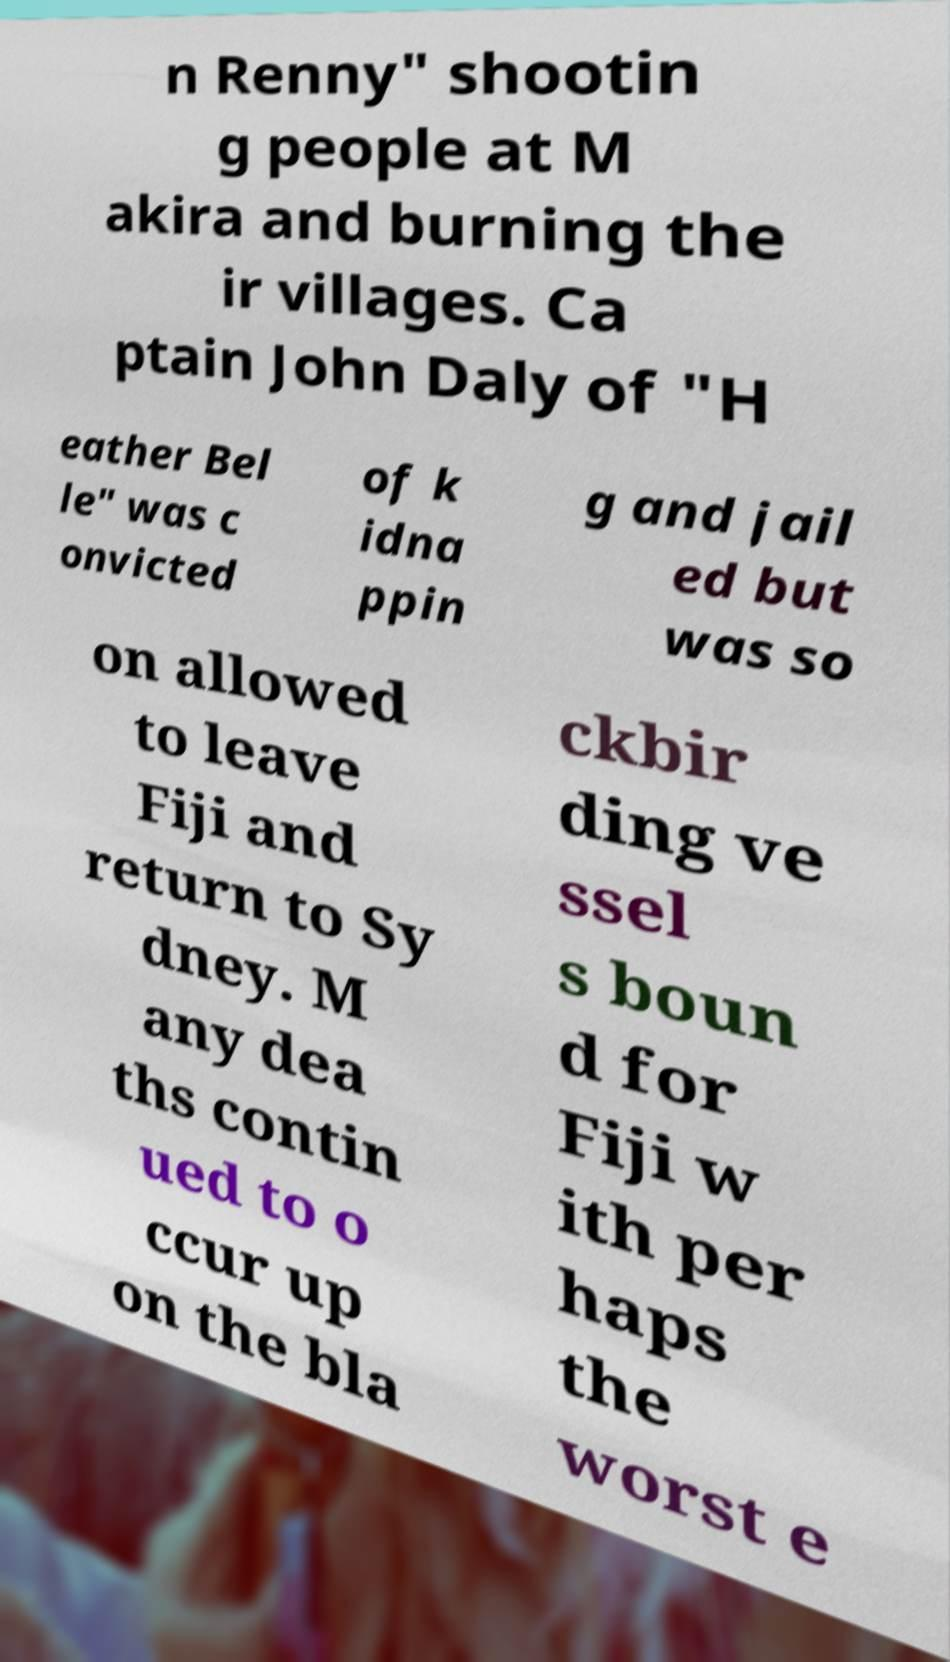Could you assist in decoding the text presented in this image and type it out clearly? n Renny" shootin g people at M akira and burning the ir villages. Ca ptain John Daly of "H eather Bel le" was c onvicted of k idna ppin g and jail ed but was so on allowed to leave Fiji and return to Sy dney. M any dea ths contin ued to o ccur up on the bla ckbir ding ve ssel s boun d for Fiji w ith per haps the worst e 